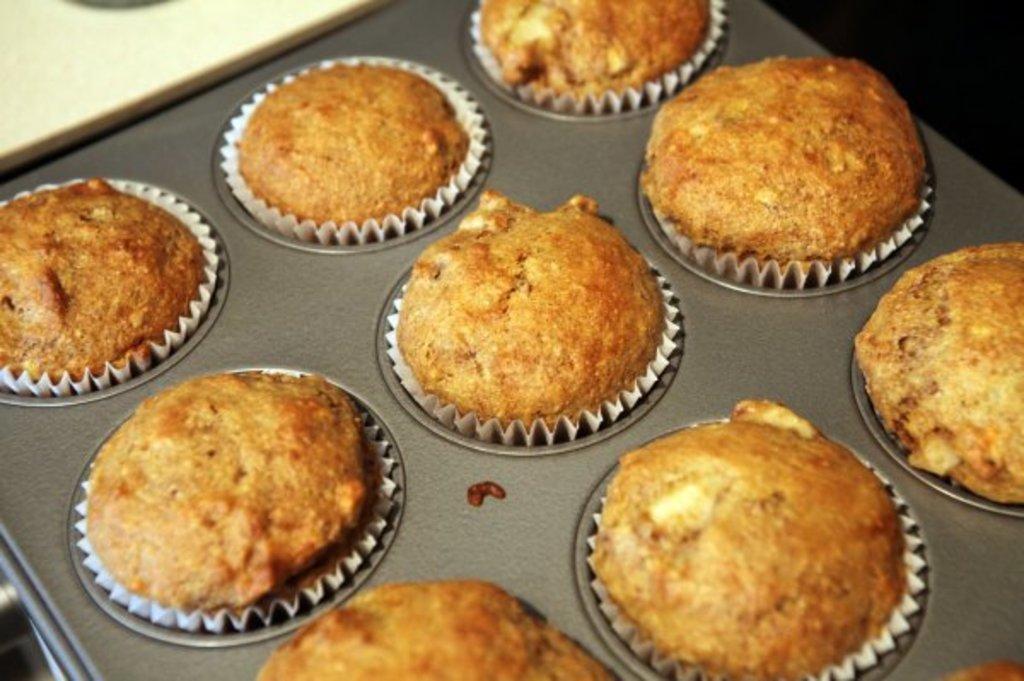Could you give a brief overview of what you see in this image? In this picture there are few cupcakes placed on an object. 